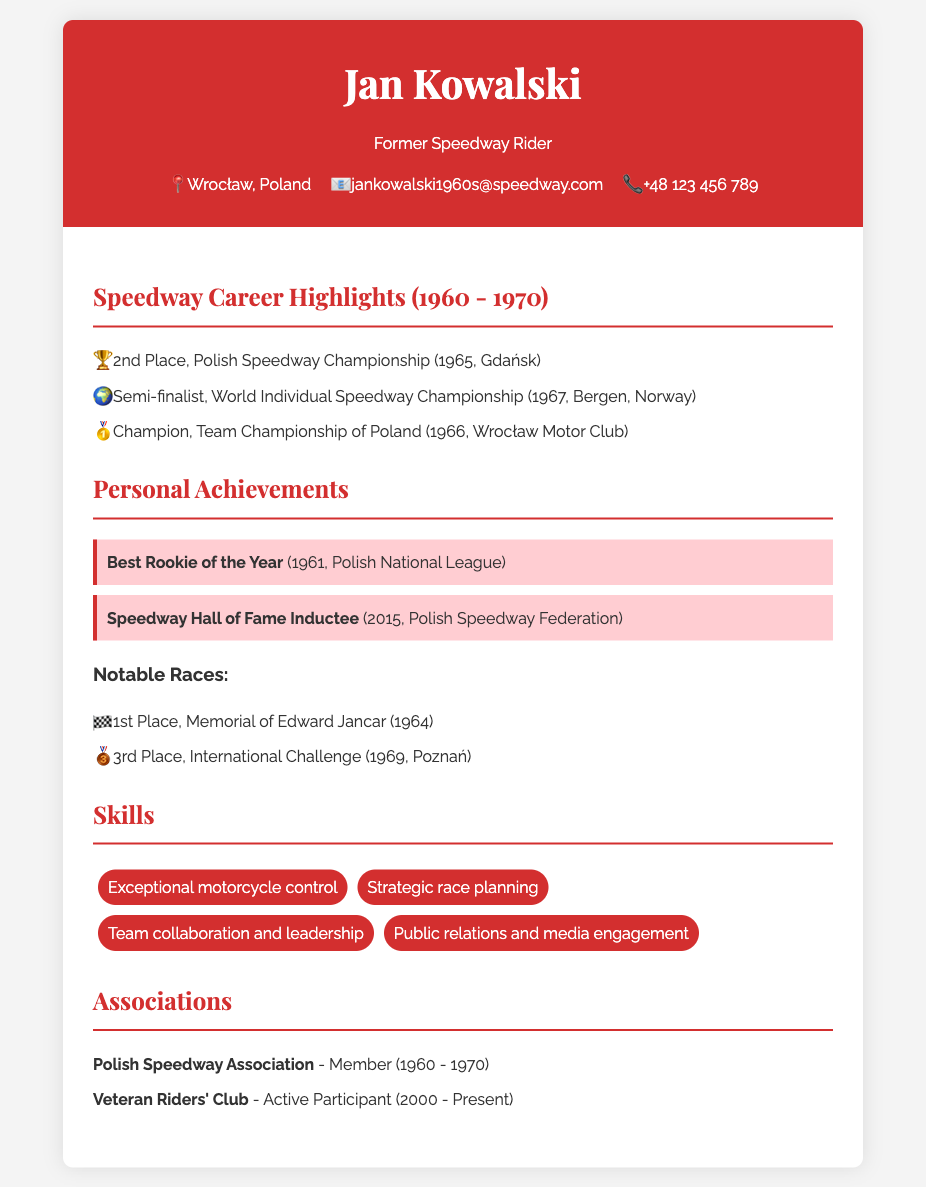What position did Jan Kowalski achieve in the Polish Speedway Championship in 1965? The document states that Jan Kowalski achieved 2nd Place in the Polish Speedway Championship in 1965.
Answer: 2nd Place In what year was Jan Kowalski inducted into the Speedway Hall of Fame? The document mentions that Jan Kowalski was inducted into the Speedway Hall of Fame in 2015.
Answer: 2015 Which club's team championship did Jan Kowalski win in 1966? The document indicates that he was the Champion of the Team Championship of Poland with the Wrocław Motor Club in 1966.
Answer: Wrocław Motor Club Which notable race did Jan Kowalski win in 1964? According to the document, he won the Memorial of Edward Jancar in 1964.
Answer: Memorial of Edward Jancar How many major competitions are listed in the highlights section? The document lists three major competitions in the highlights section of Jan Kowalski's career.
Answer: 3 What skill is related to planning races strategically? The document specifically mentions "Strategic race planning" as one of the skills Jan Kowalski possesses.
Answer: Strategic race planning Which association did Jan Kowalski belong to from 1960 to 1970? The document states that he was a Member of the Polish Speedway Association from 1960 to 1970.
Answer: Polish Speedway Association In which city did Jan Kowalski achieve 3rd place in the International Challenge? The document states that he achieved 3rd place in the International Challenge held in Poznań in 1969.
Answer: Poznań What is the name of the club where Jan Kowalski is an active participant since 2000? The document indicates he is an active participant in the Veteran Riders' Club since 2000.
Answer: Veteran Riders' Club 